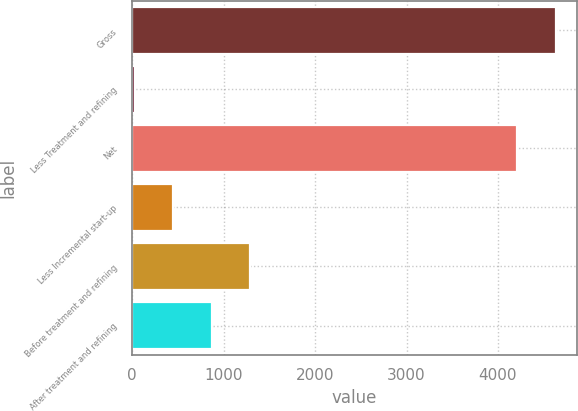Convert chart to OTSL. <chart><loc_0><loc_0><loc_500><loc_500><bar_chart><fcel>Gross<fcel>Less Treatment and refining<fcel>Net<fcel>Less Incremental start-up<fcel>Before treatment and refining<fcel>After treatment and refining<nl><fcel>4632.1<fcel>30<fcel>4211<fcel>451.1<fcel>1293.3<fcel>872.2<nl></chart> 